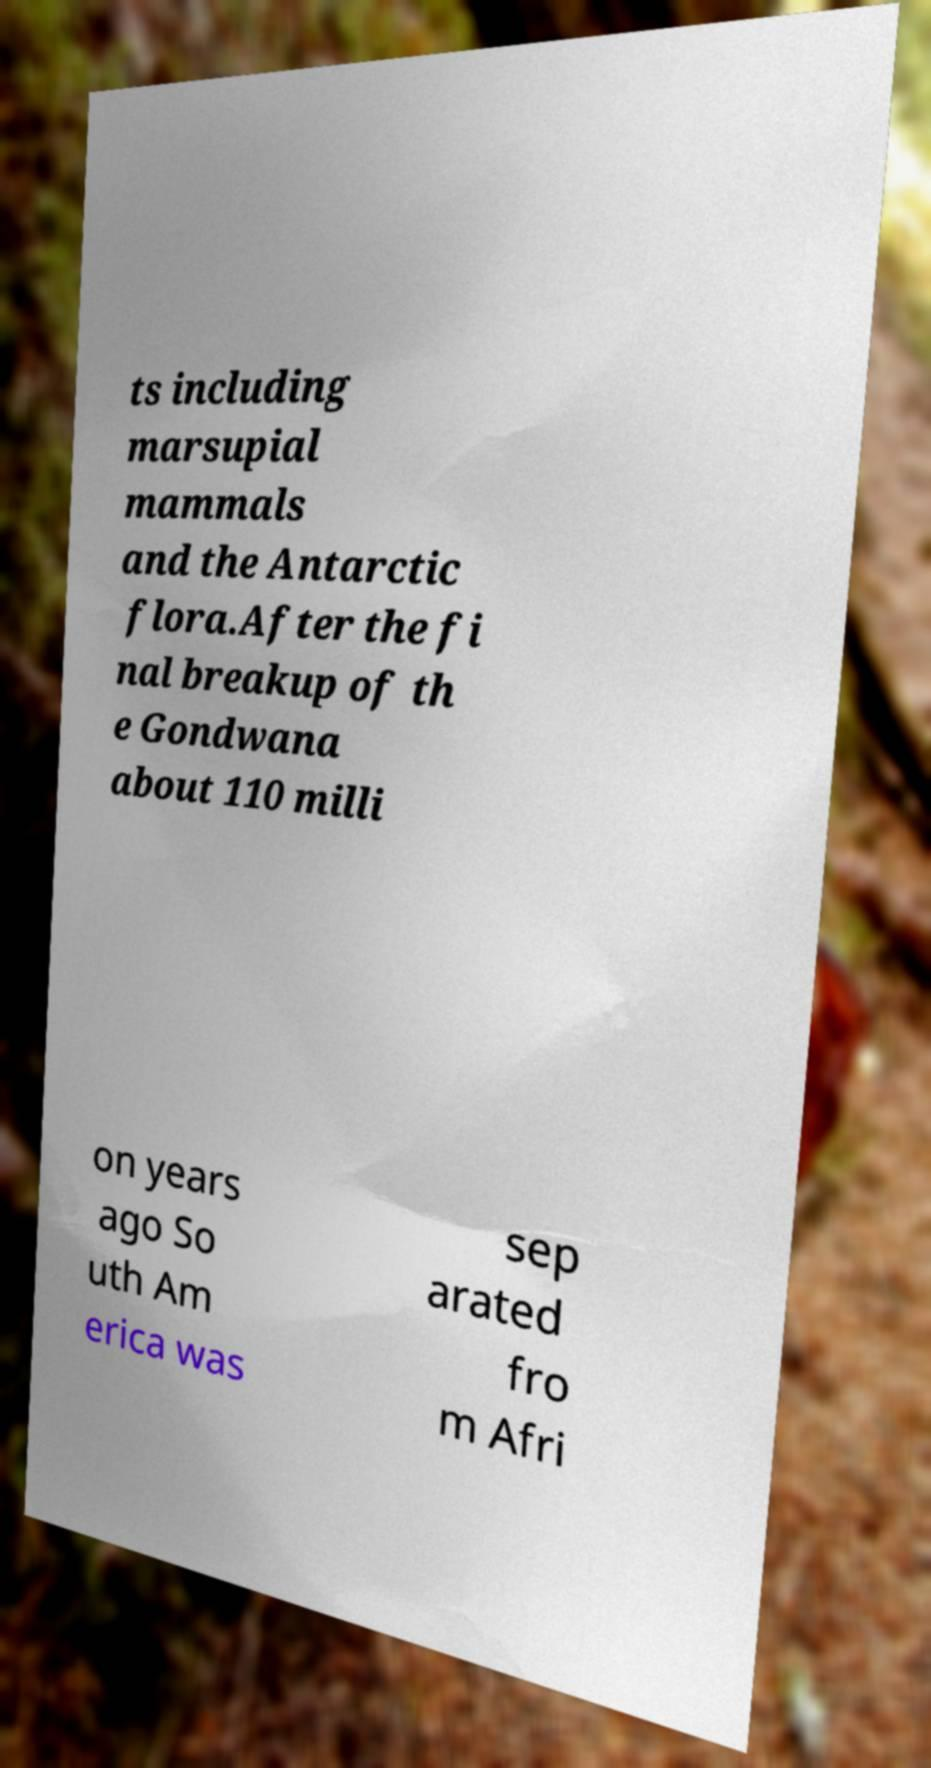Please identify and transcribe the text found in this image. ts including marsupial mammals and the Antarctic flora.After the fi nal breakup of th e Gondwana about 110 milli on years ago So uth Am erica was sep arated fro m Afri 